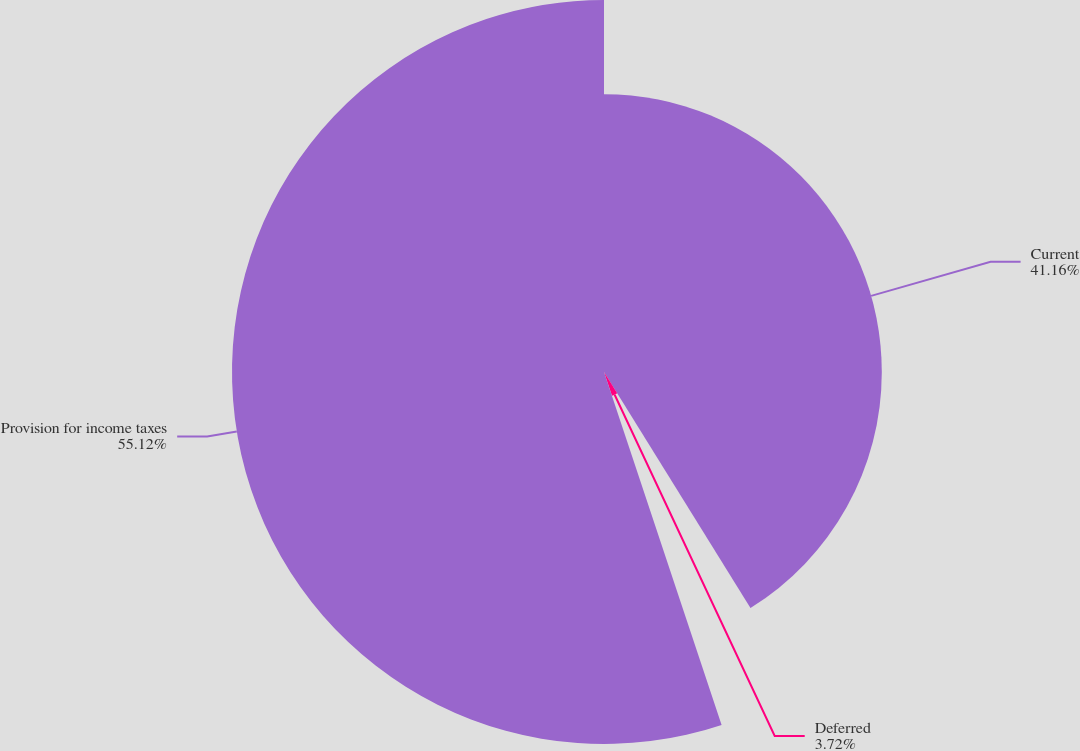Convert chart to OTSL. <chart><loc_0><loc_0><loc_500><loc_500><pie_chart><fcel>Current<fcel>Deferred<fcel>Provision for income taxes<nl><fcel>41.16%<fcel>3.72%<fcel>55.12%<nl></chart> 